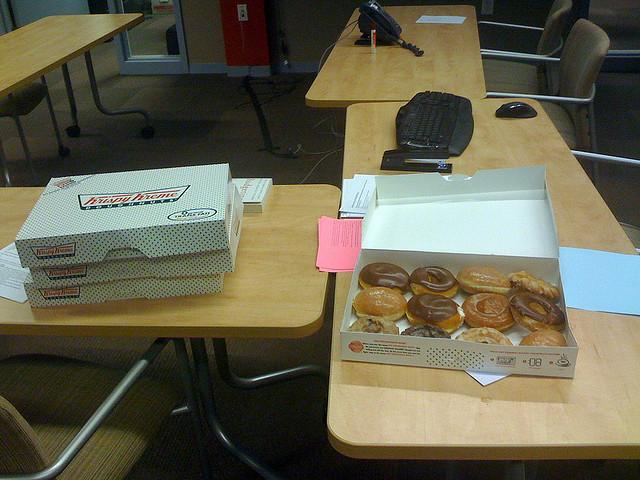Who is a competitor of this company? dunkin donuts 